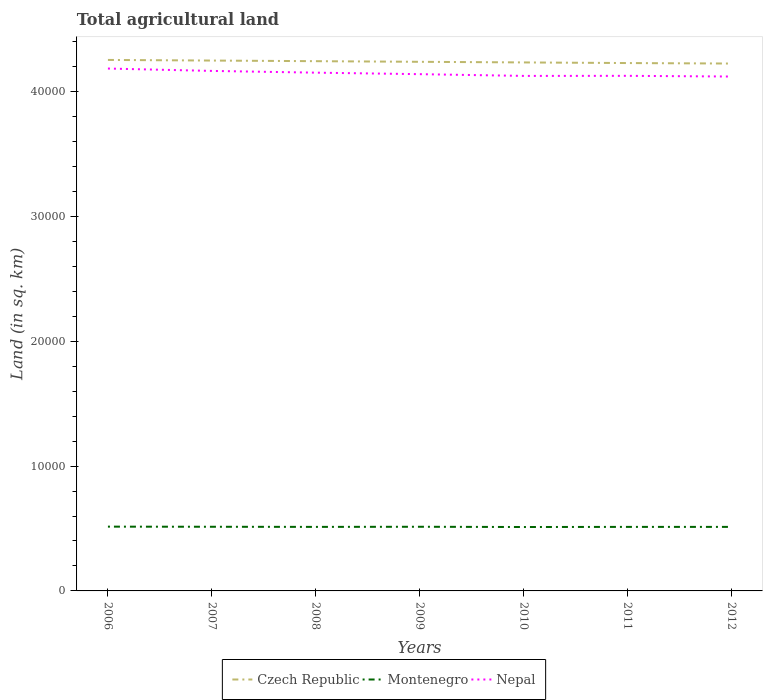Is the number of lines equal to the number of legend labels?
Provide a short and direct response. Yes. Across all years, what is the maximum total agricultural land in Czech Republic?
Make the answer very short. 4.22e+04. What is the total total agricultural land in Czech Republic in the graph?
Provide a succinct answer. 50. What is the difference between the highest and the second highest total agricultural land in Nepal?
Offer a terse response. 640. What is the difference between the highest and the lowest total agricultural land in Nepal?
Your answer should be compact. 3. How many lines are there?
Your answer should be compact. 3. What is the difference between two consecutive major ticks on the Y-axis?
Provide a short and direct response. 10000. Does the graph contain grids?
Provide a succinct answer. No. Where does the legend appear in the graph?
Give a very brief answer. Bottom center. What is the title of the graph?
Offer a terse response. Total agricultural land. What is the label or title of the X-axis?
Provide a short and direct response. Years. What is the label or title of the Y-axis?
Offer a very short reply. Land (in sq. km). What is the Land (in sq. km) in Czech Republic in 2006?
Provide a succinct answer. 4.25e+04. What is the Land (in sq. km) of Montenegro in 2006?
Give a very brief answer. 5150. What is the Land (in sq. km) of Nepal in 2006?
Keep it short and to the point. 4.18e+04. What is the Land (in sq. km) in Czech Republic in 2007?
Provide a short and direct response. 4.25e+04. What is the Land (in sq. km) of Montenegro in 2007?
Offer a very short reply. 5140. What is the Land (in sq. km) in Nepal in 2007?
Offer a terse response. 4.17e+04. What is the Land (in sq. km) in Czech Republic in 2008?
Keep it short and to the point. 4.24e+04. What is the Land (in sq. km) of Montenegro in 2008?
Offer a terse response. 5130. What is the Land (in sq. km) of Nepal in 2008?
Give a very brief answer. 4.15e+04. What is the Land (in sq. km) of Czech Republic in 2009?
Your response must be concise. 4.24e+04. What is the Land (in sq. km) of Montenegro in 2009?
Your answer should be compact. 5140. What is the Land (in sq. km) of Nepal in 2009?
Offer a terse response. 4.14e+04. What is the Land (in sq. km) in Czech Republic in 2010?
Your answer should be compact. 4.23e+04. What is the Land (in sq. km) in Montenegro in 2010?
Your response must be concise. 5120. What is the Land (in sq. km) in Nepal in 2010?
Your response must be concise. 4.13e+04. What is the Land (in sq. km) of Czech Republic in 2011?
Ensure brevity in your answer.  4.23e+04. What is the Land (in sq. km) in Montenegro in 2011?
Ensure brevity in your answer.  5130. What is the Land (in sq. km) in Nepal in 2011?
Offer a very short reply. 4.13e+04. What is the Land (in sq. km) of Czech Republic in 2012?
Ensure brevity in your answer.  4.22e+04. What is the Land (in sq. km) in Montenegro in 2012?
Make the answer very short. 5130. What is the Land (in sq. km) in Nepal in 2012?
Ensure brevity in your answer.  4.12e+04. Across all years, what is the maximum Land (in sq. km) of Czech Republic?
Provide a short and direct response. 4.25e+04. Across all years, what is the maximum Land (in sq. km) of Montenegro?
Provide a short and direct response. 5150. Across all years, what is the maximum Land (in sq. km) of Nepal?
Provide a short and direct response. 4.18e+04. Across all years, what is the minimum Land (in sq. km) of Czech Republic?
Ensure brevity in your answer.  4.22e+04. Across all years, what is the minimum Land (in sq. km) of Montenegro?
Make the answer very short. 5120. Across all years, what is the minimum Land (in sq. km) of Nepal?
Your answer should be compact. 4.12e+04. What is the total Land (in sq. km) of Czech Republic in the graph?
Offer a terse response. 2.97e+05. What is the total Land (in sq. km) of Montenegro in the graph?
Make the answer very short. 3.59e+04. What is the total Land (in sq. km) of Nepal in the graph?
Provide a short and direct response. 2.90e+05. What is the difference between the Land (in sq. km) in Czech Republic in 2006 and that in 2007?
Offer a terse response. 50. What is the difference between the Land (in sq. km) of Nepal in 2006 and that in 2007?
Give a very brief answer. 190. What is the difference between the Land (in sq. km) in Nepal in 2006 and that in 2008?
Make the answer very short. 330. What is the difference between the Land (in sq. km) of Czech Republic in 2006 and that in 2009?
Keep it short and to the point. 150. What is the difference between the Land (in sq. km) of Montenegro in 2006 and that in 2009?
Keep it short and to the point. 10. What is the difference between the Land (in sq. km) of Nepal in 2006 and that in 2009?
Provide a succinct answer. 450. What is the difference between the Land (in sq. km) in Czech Republic in 2006 and that in 2010?
Offer a terse response. 200. What is the difference between the Land (in sq. km) of Nepal in 2006 and that in 2010?
Offer a very short reply. 590. What is the difference between the Land (in sq. km) of Czech Republic in 2006 and that in 2011?
Provide a short and direct response. 250. What is the difference between the Land (in sq. km) in Montenegro in 2006 and that in 2011?
Provide a short and direct response. 20. What is the difference between the Land (in sq. km) in Nepal in 2006 and that in 2011?
Keep it short and to the point. 584. What is the difference between the Land (in sq. km) in Czech Republic in 2006 and that in 2012?
Make the answer very short. 290. What is the difference between the Land (in sq. km) in Montenegro in 2006 and that in 2012?
Give a very brief answer. 20. What is the difference between the Land (in sq. km) of Nepal in 2006 and that in 2012?
Your response must be concise. 640. What is the difference between the Land (in sq. km) in Nepal in 2007 and that in 2008?
Your response must be concise. 140. What is the difference between the Land (in sq. km) in Nepal in 2007 and that in 2009?
Keep it short and to the point. 260. What is the difference between the Land (in sq. km) of Czech Republic in 2007 and that in 2010?
Provide a succinct answer. 150. What is the difference between the Land (in sq. km) of Nepal in 2007 and that in 2010?
Your answer should be compact. 400. What is the difference between the Land (in sq. km) in Nepal in 2007 and that in 2011?
Ensure brevity in your answer.  394. What is the difference between the Land (in sq. km) of Czech Republic in 2007 and that in 2012?
Your response must be concise. 240. What is the difference between the Land (in sq. km) in Nepal in 2007 and that in 2012?
Make the answer very short. 450. What is the difference between the Land (in sq. km) in Nepal in 2008 and that in 2009?
Offer a very short reply. 120. What is the difference between the Land (in sq. km) of Czech Republic in 2008 and that in 2010?
Keep it short and to the point. 100. What is the difference between the Land (in sq. km) of Nepal in 2008 and that in 2010?
Ensure brevity in your answer.  260. What is the difference between the Land (in sq. km) of Czech Republic in 2008 and that in 2011?
Provide a succinct answer. 150. What is the difference between the Land (in sq. km) of Montenegro in 2008 and that in 2011?
Make the answer very short. 0. What is the difference between the Land (in sq. km) of Nepal in 2008 and that in 2011?
Offer a very short reply. 254. What is the difference between the Land (in sq. km) in Czech Republic in 2008 and that in 2012?
Make the answer very short. 190. What is the difference between the Land (in sq. km) in Nepal in 2008 and that in 2012?
Make the answer very short. 310. What is the difference between the Land (in sq. km) in Czech Republic in 2009 and that in 2010?
Keep it short and to the point. 50. What is the difference between the Land (in sq. km) of Montenegro in 2009 and that in 2010?
Your answer should be compact. 20. What is the difference between the Land (in sq. km) of Nepal in 2009 and that in 2010?
Keep it short and to the point. 140. What is the difference between the Land (in sq. km) of Montenegro in 2009 and that in 2011?
Keep it short and to the point. 10. What is the difference between the Land (in sq. km) of Nepal in 2009 and that in 2011?
Your answer should be very brief. 134. What is the difference between the Land (in sq. km) in Czech Republic in 2009 and that in 2012?
Provide a succinct answer. 140. What is the difference between the Land (in sq. km) of Nepal in 2009 and that in 2012?
Your answer should be very brief. 190. What is the difference between the Land (in sq. km) in Montenegro in 2010 and that in 2011?
Provide a succinct answer. -10. What is the difference between the Land (in sq. km) of Nepal in 2010 and that in 2011?
Provide a short and direct response. -6. What is the difference between the Land (in sq. km) in Czech Republic in 2010 and that in 2012?
Keep it short and to the point. 90. What is the difference between the Land (in sq. km) in Nepal in 2010 and that in 2012?
Ensure brevity in your answer.  50. What is the difference between the Land (in sq. km) in Czech Republic in 2011 and that in 2012?
Your answer should be very brief. 40. What is the difference between the Land (in sq. km) of Nepal in 2011 and that in 2012?
Give a very brief answer. 56. What is the difference between the Land (in sq. km) of Czech Republic in 2006 and the Land (in sq. km) of Montenegro in 2007?
Provide a short and direct response. 3.74e+04. What is the difference between the Land (in sq. km) in Czech Republic in 2006 and the Land (in sq. km) in Nepal in 2007?
Offer a terse response. 880. What is the difference between the Land (in sq. km) in Montenegro in 2006 and the Land (in sq. km) in Nepal in 2007?
Offer a very short reply. -3.65e+04. What is the difference between the Land (in sq. km) in Czech Republic in 2006 and the Land (in sq. km) in Montenegro in 2008?
Offer a terse response. 3.74e+04. What is the difference between the Land (in sq. km) in Czech Republic in 2006 and the Land (in sq. km) in Nepal in 2008?
Your response must be concise. 1020. What is the difference between the Land (in sq. km) of Montenegro in 2006 and the Land (in sq. km) of Nepal in 2008?
Give a very brief answer. -3.64e+04. What is the difference between the Land (in sq. km) in Czech Republic in 2006 and the Land (in sq. km) in Montenegro in 2009?
Make the answer very short. 3.74e+04. What is the difference between the Land (in sq. km) of Czech Republic in 2006 and the Land (in sq. km) of Nepal in 2009?
Provide a succinct answer. 1140. What is the difference between the Land (in sq. km) of Montenegro in 2006 and the Land (in sq. km) of Nepal in 2009?
Offer a very short reply. -3.62e+04. What is the difference between the Land (in sq. km) in Czech Republic in 2006 and the Land (in sq. km) in Montenegro in 2010?
Your answer should be very brief. 3.74e+04. What is the difference between the Land (in sq. km) of Czech Republic in 2006 and the Land (in sq. km) of Nepal in 2010?
Make the answer very short. 1280. What is the difference between the Land (in sq. km) of Montenegro in 2006 and the Land (in sq. km) of Nepal in 2010?
Your answer should be compact. -3.61e+04. What is the difference between the Land (in sq. km) in Czech Republic in 2006 and the Land (in sq. km) in Montenegro in 2011?
Offer a terse response. 3.74e+04. What is the difference between the Land (in sq. km) of Czech Republic in 2006 and the Land (in sq. km) of Nepal in 2011?
Offer a terse response. 1274. What is the difference between the Land (in sq. km) of Montenegro in 2006 and the Land (in sq. km) of Nepal in 2011?
Give a very brief answer. -3.61e+04. What is the difference between the Land (in sq. km) of Czech Republic in 2006 and the Land (in sq. km) of Montenegro in 2012?
Ensure brevity in your answer.  3.74e+04. What is the difference between the Land (in sq. km) of Czech Republic in 2006 and the Land (in sq. km) of Nepal in 2012?
Provide a short and direct response. 1330. What is the difference between the Land (in sq. km) in Montenegro in 2006 and the Land (in sq. km) in Nepal in 2012?
Your answer should be compact. -3.61e+04. What is the difference between the Land (in sq. km) of Czech Republic in 2007 and the Land (in sq. km) of Montenegro in 2008?
Your answer should be compact. 3.74e+04. What is the difference between the Land (in sq. km) in Czech Republic in 2007 and the Land (in sq. km) in Nepal in 2008?
Give a very brief answer. 970. What is the difference between the Land (in sq. km) in Montenegro in 2007 and the Land (in sq. km) in Nepal in 2008?
Offer a very short reply. -3.64e+04. What is the difference between the Land (in sq. km) of Czech Republic in 2007 and the Land (in sq. km) of Montenegro in 2009?
Give a very brief answer. 3.74e+04. What is the difference between the Land (in sq. km) of Czech Republic in 2007 and the Land (in sq. km) of Nepal in 2009?
Keep it short and to the point. 1090. What is the difference between the Land (in sq. km) of Montenegro in 2007 and the Land (in sq. km) of Nepal in 2009?
Ensure brevity in your answer.  -3.63e+04. What is the difference between the Land (in sq. km) of Czech Republic in 2007 and the Land (in sq. km) of Montenegro in 2010?
Make the answer very short. 3.74e+04. What is the difference between the Land (in sq. km) of Czech Republic in 2007 and the Land (in sq. km) of Nepal in 2010?
Provide a succinct answer. 1230. What is the difference between the Land (in sq. km) of Montenegro in 2007 and the Land (in sq. km) of Nepal in 2010?
Provide a short and direct response. -3.61e+04. What is the difference between the Land (in sq. km) of Czech Republic in 2007 and the Land (in sq. km) of Montenegro in 2011?
Provide a succinct answer. 3.74e+04. What is the difference between the Land (in sq. km) in Czech Republic in 2007 and the Land (in sq. km) in Nepal in 2011?
Provide a short and direct response. 1224. What is the difference between the Land (in sq. km) of Montenegro in 2007 and the Land (in sq. km) of Nepal in 2011?
Provide a succinct answer. -3.61e+04. What is the difference between the Land (in sq. km) of Czech Republic in 2007 and the Land (in sq. km) of Montenegro in 2012?
Ensure brevity in your answer.  3.74e+04. What is the difference between the Land (in sq. km) in Czech Republic in 2007 and the Land (in sq. km) in Nepal in 2012?
Your answer should be very brief. 1280. What is the difference between the Land (in sq. km) in Montenegro in 2007 and the Land (in sq. km) in Nepal in 2012?
Offer a very short reply. -3.61e+04. What is the difference between the Land (in sq. km) of Czech Republic in 2008 and the Land (in sq. km) of Montenegro in 2009?
Provide a succinct answer. 3.73e+04. What is the difference between the Land (in sq. km) in Czech Republic in 2008 and the Land (in sq. km) in Nepal in 2009?
Provide a succinct answer. 1040. What is the difference between the Land (in sq. km) of Montenegro in 2008 and the Land (in sq. km) of Nepal in 2009?
Your answer should be compact. -3.63e+04. What is the difference between the Land (in sq. km) of Czech Republic in 2008 and the Land (in sq. km) of Montenegro in 2010?
Keep it short and to the point. 3.73e+04. What is the difference between the Land (in sq. km) in Czech Republic in 2008 and the Land (in sq. km) in Nepal in 2010?
Ensure brevity in your answer.  1180. What is the difference between the Land (in sq. km) of Montenegro in 2008 and the Land (in sq. km) of Nepal in 2010?
Your answer should be compact. -3.61e+04. What is the difference between the Land (in sq. km) in Czech Republic in 2008 and the Land (in sq. km) in Montenegro in 2011?
Make the answer very short. 3.73e+04. What is the difference between the Land (in sq. km) of Czech Republic in 2008 and the Land (in sq. km) of Nepal in 2011?
Your answer should be very brief. 1174. What is the difference between the Land (in sq. km) of Montenegro in 2008 and the Land (in sq. km) of Nepal in 2011?
Offer a very short reply. -3.61e+04. What is the difference between the Land (in sq. km) of Czech Republic in 2008 and the Land (in sq. km) of Montenegro in 2012?
Offer a terse response. 3.73e+04. What is the difference between the Land (in sq. km) in Czech Republic in 2008 and the Land (in sq. km) in Nepal in 2012?
Keep it short and to the point. 1230. What is the difference between the Land (in sq. km) in Montenegro in 2008 and the Land (in sq. km) in Nepal in 2012?
Your answer should be very brief. -3.61e+04. What is the difference between the Land (in sq. km) in Czech Republic in 2009 and the Land (in sq. km) in Montenegro in 2010?
Provide a succinct answer. 3.73e+04. What is the difference between the Land (in sq. km) of Czech Republic in 2009 and the Land (in sq. km) of Nepal in 2010?
Provide a short and direct response. 1130. What is the difference between the Land (in sq. km) of Montenegro in 2009 and the Land (in sq. km) of Nepal in 2010?
Keep it short and to the point. -3.61e+04. What is the difference between the Land (in sq. km) of Czech Republic in 2009 and the Land (in sq. km) of Montenegro in 2011?
Keep it short and to the point. 3.73e+04. What is the difference between the Land (in sq. km) of Czech Republic in 2009 and the Land (in sq. km) of Nepal in 2011?
Your answer should be compact. 1124. What is the difference between the Land (in sq. km) in Montenegro in 2009 and the Land (in sq. km) in Nepal in 2011?
Keep it short and to the point. -3.61e+04. What is the difference between the Land (in sq. km) of Czech Republic in 2009 and the Land (in sq. km) of Montenegro in 2012?
Keep it short and to the point. 3.73e+04. What is the difference between the Land (in sq. km) of Czech Republic in 2009 and the Land (in sq. km) of Nepal in 2012?
Provide a short and direct response. 1180. What is the difference between the Land (in sq. km) in Montenegro in 2009 and the Land (in sq. km) in Nepal in 2012?
Your answer should be very brief. -3.61e+04. What is the difference between the Land (in sq. km) of Czech Republic in 2010 and the Land (in sq. km) of Montenegro in 2011?
Provide a short and direct response. 3.72e+04. What is the difference between the Land (in sq. km) of Czech Republic in 2010 and the Land (in sq. km) of Nepal in 2011?
Offer a very short reply. 1074. What is the difference between the Land (in sq. km) of Montenegro in 2010 and the Land (in sq. km) of Nepal in 2011?
Provide a succinct answer. -3.61e+04. What is the difference between the Land (in sq. km) in Czech Republic in 2010 and the Land (in sq. km) in Montenegro in 2012?
Your answer should be compact. 3.72e+04. What is the difference between the Land (in sq. km) in Czech Republic in 2010 and the Land (in sq. km) in Nepal in 2012?
Ensure brevity in your answer.  1130. What is the difference between the Land (in sq. km) in Montenegro in 2010 and the Land (in sq. km) in Nepal in 2012?
Your answer should be very brief. -3.61e+04. What is the difference between the Land (in sq. km) of Czech Republic in 2011 and the Land (in sq. km) of Montenegro in 2012?
Provide a short and direct response. 3.72e+04. What is the difference between the Land (in sq. km) in Czech Republic in 2011 and the Land (in sq. km) in Nepal in 2012?
Give a very brief answer. 1080. What is the difference between the Land (in sq. km) in Montenegro in 2011 and the Land (in sq. km) in Nepal in 2012?
Your response must be concise. -3.61e+04. What is the average Land (in sq. km) in Czech Republic per year?
Your response must be concise. 4.24e+04. What is the average Land (in sq. km) in Montenegro per year?
Your answer should be very brief. 5134.29. What is the average Land (in sq. km) in Nepal per year?
Provide a succinct answer. 4.15e+04. In the year 2006, what is the difference between the Land (in sq. km) in Czech Republic and Land (in sq. km) in Montenegro?
Offer a terse response. 3.74e+04. In the year 2006, what is the difference between the Land (in sq. km) in Czech Republic and Land (in sq. km) in Nepal?
Offer a very short reply. 690. In the year 2006, what is the difference between the Land (in sq. km) of Montenegro and Land (in sq. km) of Nepal?
Provide a succinct answer. -3.67e+04. In the year 2007, what is the difference between the Land (in sq. km) in Czech Republic and Land (in sq. km) in Montenegro?
Your answer should be compact. 3.74e+04. In the year 2007, what is the difference between the Land (in sq. km) of Czech Republic and Land (in sq. km) of Nepal?
Make the answer very short. 830. In the year 2007, what is the difference between the Land (in sq. km) of Montenegro and Land (in sq. km) of Nepal?
Give a very brief answer. -3.65e+04. In the year 2008, what is the difference between the Land (in sq. km) in Czech Republic and Land (in sq. km) in Montenegro?
Your answer should be very brief. 3.73e+04. In the year 2008, what is the difference between the Land (in sq. km) in Czech Republic and Land (in sq. km) in Nepal?
Provide a short and direct response. 920. In the year 2008, what is the difference between the Land (in sq. km) of Montenegro and Land (in sq. km) of Nepal?
Provide a succinct answer. -3.64e+04. In the year 2009, what is the difference between the Land (in sq. km) of Czech Republic and Land (in sq. km) of Montenegro?
Keep it short and to the point. 3.72e+04. In the year 2009, what is the difference between the Land (in sq. km) of Czech Republic and Land (in sq. km) of Nepal?
Give a very brief answer. 990. In the year 2009, what is the difference between the Land (in sq. km) of Montenegro and Land (in sq. km) of Nepal?
Keep it short and to the point. -3.63e+04. In the year 2010, what is the difference between the Land (in sq. km) of Czech Republic and Land (in sq. km) of Montenegro?
Your answer should be compact. 3.72e+04. In the year 2010, what is the difference between the Land (in sq. km) in Czech Republic and Land (in sq. km) in Nepal?
Your answer should be very brief. 1080. In the year 2010, what is the difference between the Land (in sq. km) in Montenegro and Land (in sq. km) in Nepal?
Provide a short and direct response. -3.61e+04. In the year 2011, what is the difference between the Land (in sq. km) of Czech Republic and Land (in sq. km) of Montenegro?
Make the answer very short. 3.72e+04. In the year 2011, what is the difference between the Land (in sq. km) in Czech Republic and Land (in sq. km) in Nepal?
Offer a very short reply. 1024. In the year 2011, what is the difference between the Land (in sq. km) in Montenegro and Land (in sq. km) in Nepal?
Provide a short and direct response. -3.61e+04. In the year 2012, what is the difference between the Land (in sq. km) of Czech Republic and Land (in sq. km) of Montenegro?
Ensure brevity in your answer.  3.71e+04. In the year 2012, what is the difference between the Land (in sq. km) in Czech Republic and Land (in sq. km) in Nepal?
Offer a very short reply. 1040. In the year 2012, what is the difference between the Land (in sq. km) of Montenegro and Land (in sq. km) of Nepal?
Provide a short and direct response. -3.61e+04. What is the ratio of the Land (in sq. km) of Czech Republic in 2006 to that in 2007?
Ensure brevity in your answer.  1. What is the ratio of the Land (in sq. km) of Montenegro in 2006 to that in 2007?
Give a very brief answer. 1. What is the ratio of the Land (in sq. km) in Czech Republic in 2006 to that in 2008?
Make the answer very short. 1. What is the ratio of the Land (in sq. km) in Nepal in 2006 to that in 2008?
Make the answer very short. 1.01. What is the ratio of the Land (in sq. km) of Czech Republic in 2006 to that in 2009?
Provide a succinct answer. 1. What is the ratio of the Land (in sq. km) in Nepal in 2006 to that in 2009?
Provide a short and direct response. 1.01. What is the ratio of the Land (in sq. km) of Czech Republic in 2006 to that in 2010?
Offer a terse response. 1. What is the ratio of the Land (in sq. km) of Montenegro in 2006 to that in 2010?
Your response must be concise. 1.01. What is the ratio of the Land (in sq. km) of Nepal in 2006 to that in 2010?
Your answer should be compact. 1.01. What is the ratio of the Land (in sq. km) in Czech Republic in 2006 to that in 2011?
Offer a terse response. 1.01. What is the ratio of the Land (in sq. km) in Nepal in 2006 to that in 2011?
Give a very brief answer. 1.01. What is the ratio of the Land (in sq. km) of Montenegro in 2006 to that in 2012?
Ensure brevity in your answer.  1. What is the ratio of the Land (in sq. km) in Nepal in 2006 to that in 2012?
Your answer should be very brief. 1.02. What is the ratio of the Land (in sq. km) in Montenegro in 2007 to that in 2008?
Your response must be concise. 1. What is the ratio of the Land (in sq. km) of Nepal in 2007 to that in 2008?
Make the answer very short. 1. What is the ratio of the Land (in sq. km) in Czech Republic in 2007 to that in 2009?
Provide a succinct answer. 1. What is the ratio of the Land (in sq. km) of Montenegro in 2007 to that in 2009?
Provide a succinct answer. 1. What is the ratio of the Land (in sq. km) of Czech Republic in 2007 to that in 2010?
Your answer should be very brief. 1. What is the ratio of the Land (in sq. km) of Montenegro in 2007 to that in 2010?
Keep it short and to the point. 1. What is the ratio of the Land (in sq. km) in Nepal in 2007 to that in 2010?
Make the answer very short. 1.01. What is the ratio of the Land (in sq. km) of Montenegro in 2007 to that in 2011?
Your answer should be compact. 1. What is the ratio of the Land (in sq. km) in Nepal in 2007 to that in 2011?
Your answer should be very brief. 1.01. What is the ratio of the Land (in sq. km) of Czech Republic in 2007 to that in 2012?
Give a very brief answer. 1.01. What is the ratio of the Land (in sq. km) in Montenegro in 2007 to that in 2012?
Your answer should be compact. 1. What is the ratio of the Land (in sq. km) of Nepal in 2007 to that in 2012?
Offer a terse response. 1.01. What is the ratio of the Land (in sq. km) in Czech Republic in 2008 to that in 2009?
Offer a terse response. 1. What is the ratio of the Land (in sq. km) of Nepal in 2008 to that in 2009?
Offer a very short reply. 1. What is the ratio of the Land (in sq. km) in Czech Republic in 2008 to that in 2011?
Offer a terse response. 1. What is the ratio of the Land (in sq. km) of Montenegro in 2008 to that in 2011?
Ensure brevity in your answer.  1. What is the ratio of the Land (in sq. km) of Nepal in 2008 to that in 2012?
Offer a terse response. 1.01. What is the ratio of the Land (in sq. km) in Czech Republic in 2009 to that in 2010?
Make the answer very short. 1. What is the ratio of the Land (in sq. km) in Montenegro in 2009 to that in 2010?
Ensure brevity in your answer.  1. What is the ratio of the Land (in sq. km) of Nepal in 2009 to that in 2010?
Ensure brevity in your answer.  1. What is the ratio of the Land (in sq. km) in Czech Republic in 2009 to that in 2011?
Ensure brevity in your answer.  1. What is the ratio of the Land (in sq. km) of Czech Republic in 2009 to that in 2012?
Your response must be concise. 1. What is the ratio of the Land (in sq. km) of Czech Republic in 2010 to that in 2011?
Ensure brevity in your answer.  1. What is the ratio of the Land (in sq. km) in Czech Republic in 2010 to that in 2012?
Keep it short and to the point. 1. What is the ratio of the Land (in sq. km) in Nepal in 2011 to that in 2012?
Give a very brief answer. 1. What is the difference between the highest and the second highest Land (in sq. km) of Montenegro?
Make the answer very short. 10. What is the difference between the highest and the second highest Land (in sq. km) of Nepal?
Provide a succinct answer. 190. What is the difference between the highest and the lowest Land (in sq. km) of Czech Republic?
Give a very brief answer. 290. What is the difference between the highest and the lowest Land (in sq. km) in Nepal?
Keep it short and to the point. 640. 